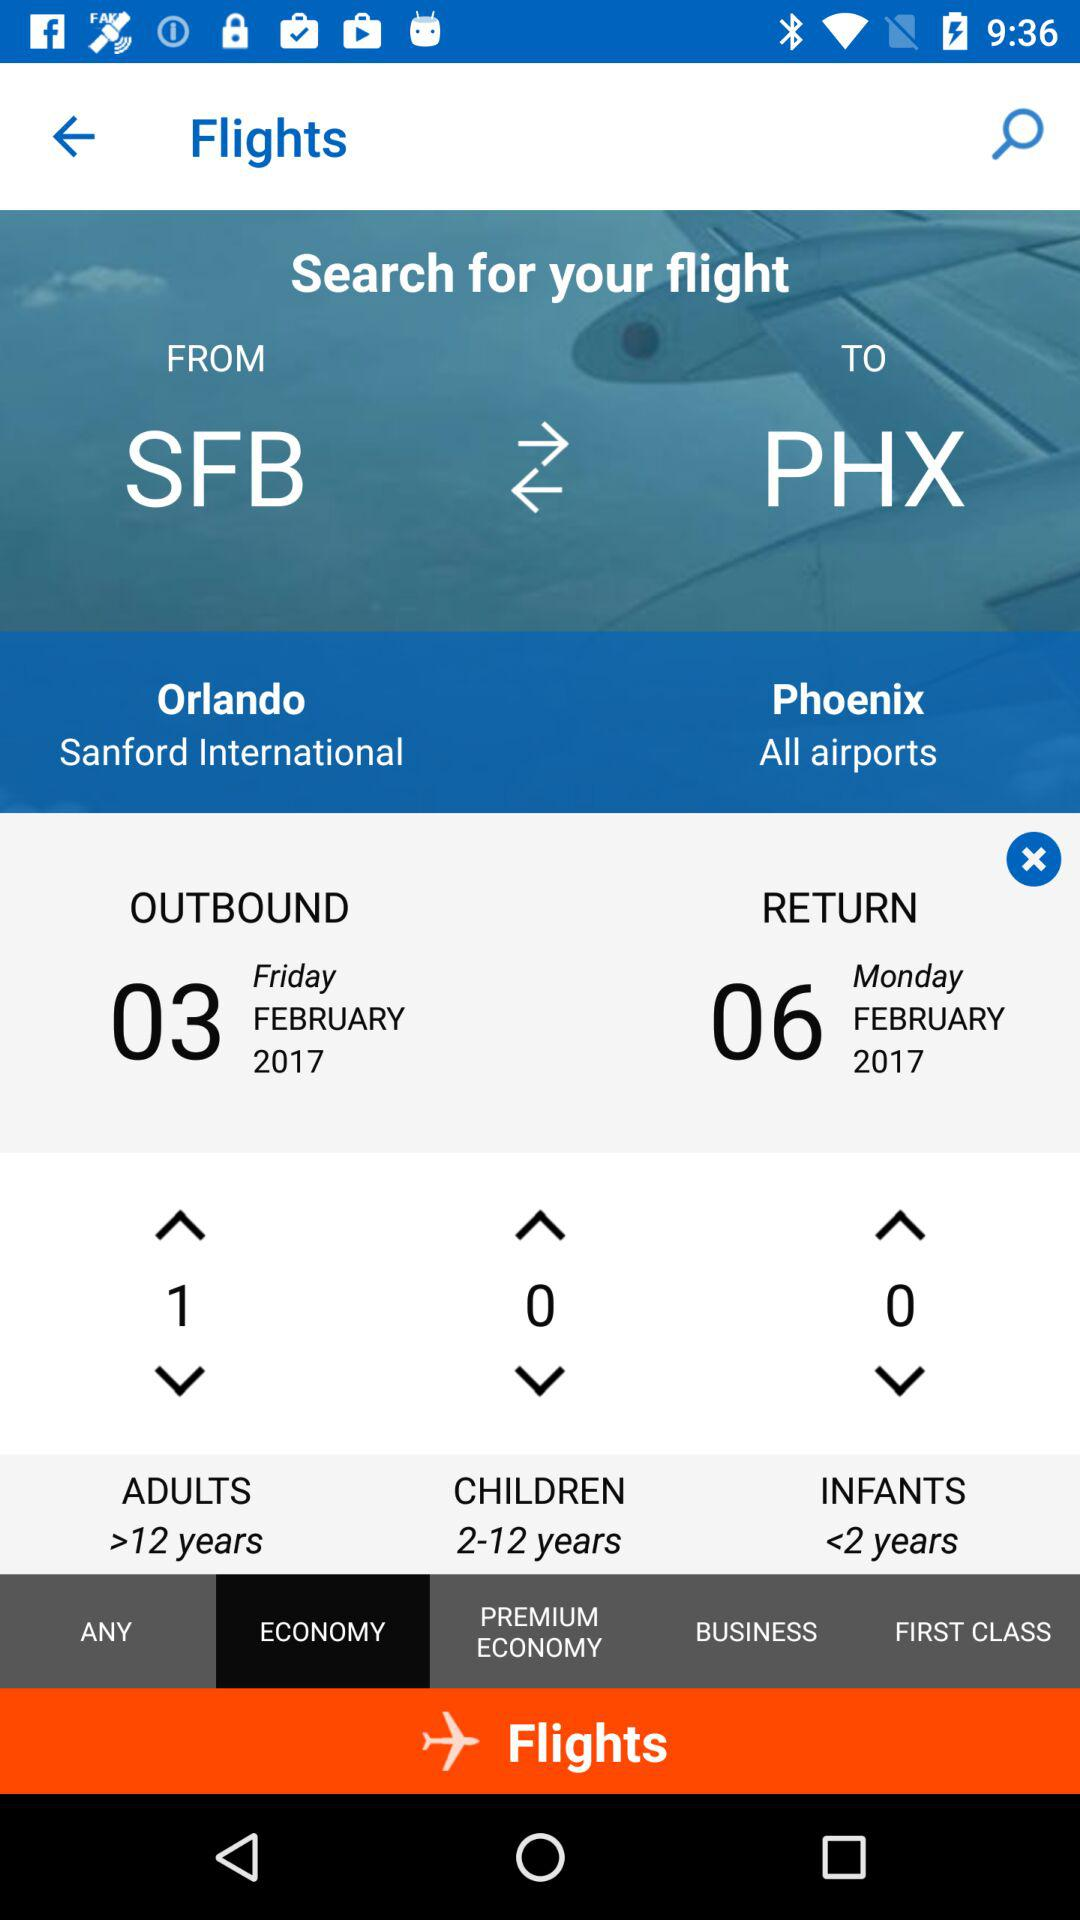What is the destination? The destination is Phoenix. 